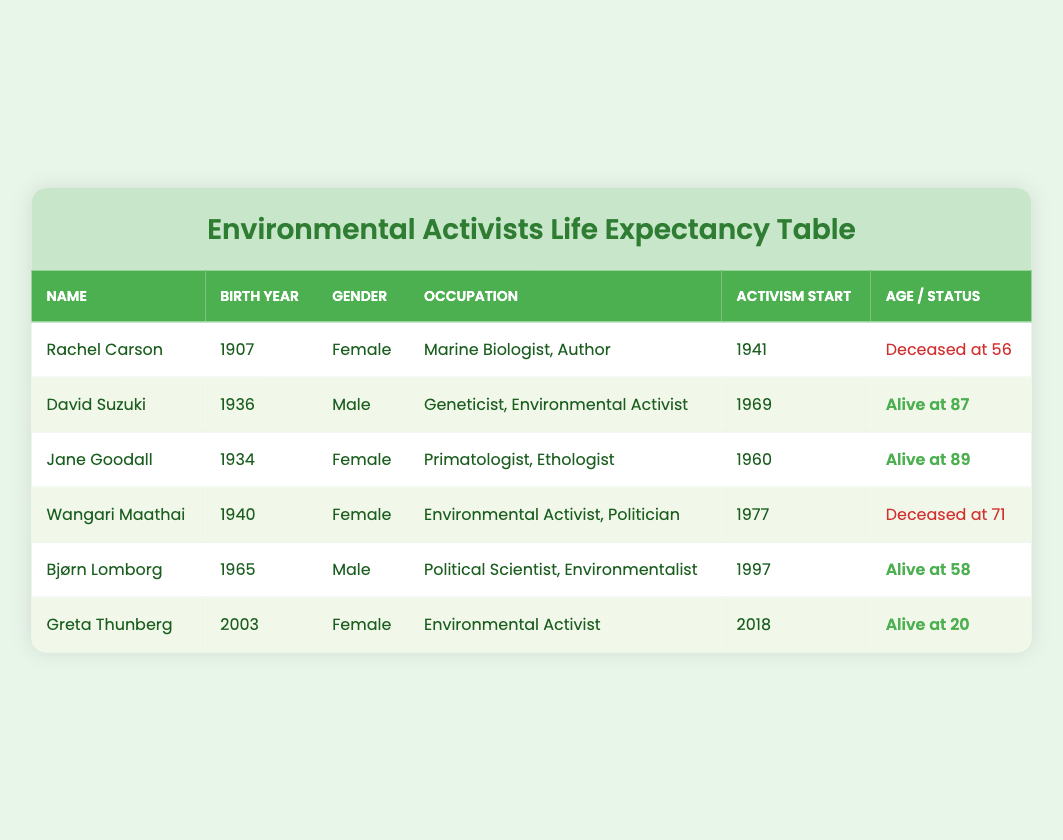What is the birth year of Rachel Carson? The table shows that Rachel Carson was born in 1907, as indicated in the "Birth Year" column next to her name.
Answer: 1907 Who has the highest age at death among the individuals listed? In the table, Rachel Carson died at 56, Wangari Maathai at 71, and the ages of David Suzuki, Jane Goodall, Bjørn Lomborg, and Greta Thunberg are unknown as they are still alive. Therefore, the highest age at death is 71 for Wangari Maathai.
Answer: 71 Is David Suzuki still alive? The table lists David Suzuki as "Alive at 87", confirming that he is indeed still alive.
Answer: Yes What is the average age at death for the deceased individuals? The only deceased individuals are Rachel Carson (56) and Wangari Maathai (71). To find the average, we add their ages: 56 + 71 = 127. Then, we divide by the number of deceased individuals (2): 127/2 = 63.5.
Answer: 63.5 Which female activist had the latest start of activism? In the table, Rachel Carson started her activism in 1941, Jane Goodall in 1960, Wangari Maathai in 1977, and Greta Thunberg in 2018. Greta Thunberg has the latest start year, 2018.
Answer: Greta Thunberg How many activists listed were born after 1940? From the table, we can see that David Suzuki (1936), Jane Goodall (1934), Wangari Maathai (1940), and Bjørn Lomborg (1965) were born post-1940. Counting them gives us 3 born after: Bjørn Lomborg (1965) and Greta Thunberg (2003).
Answer: 3 What is the occupation of Jane Goodall? The table indicates Jane Goodall's occupation as "Primatologist, Ethologist." This information is directly found in the column labeled "Occupation."
Answer: Primatologist, Ethologist What is the gender of the youngest activist listed? Greta Thunberg, who was born in 2003, is the youngest individual listed. The table indicates that she is female, thus her gender is female.
Answer: Female 